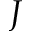Convert formula to latex. <formula><loc_0><loc_0><loc_500><loc_500>J</formula> 